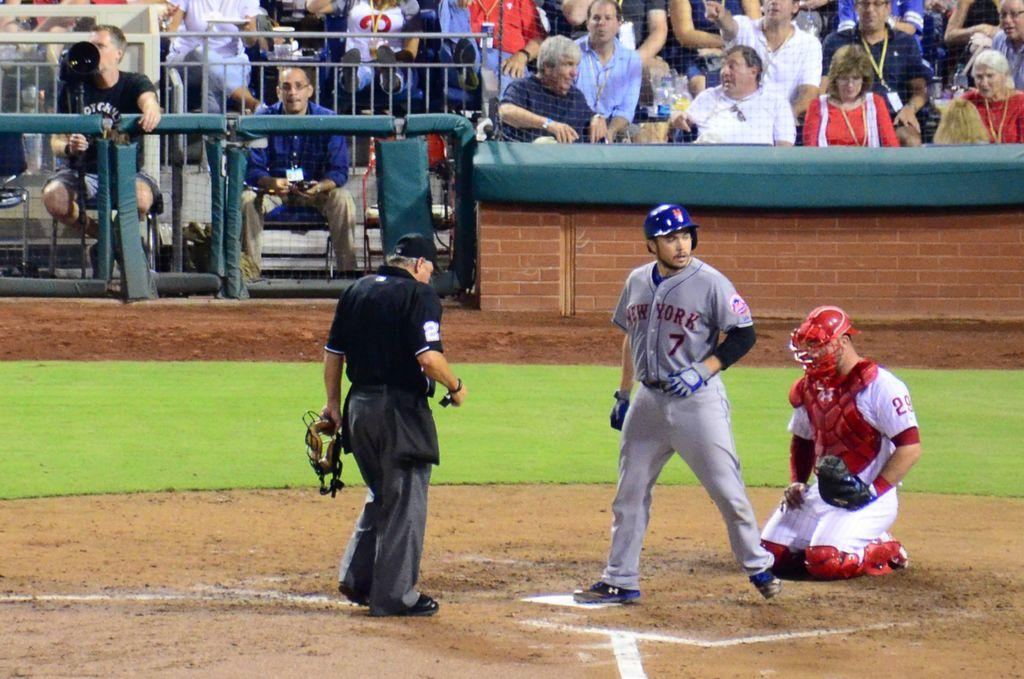<image>
Share a concise interpretation of the image provided. Some sports players, one of whom has the number 29 on his sleeve. 